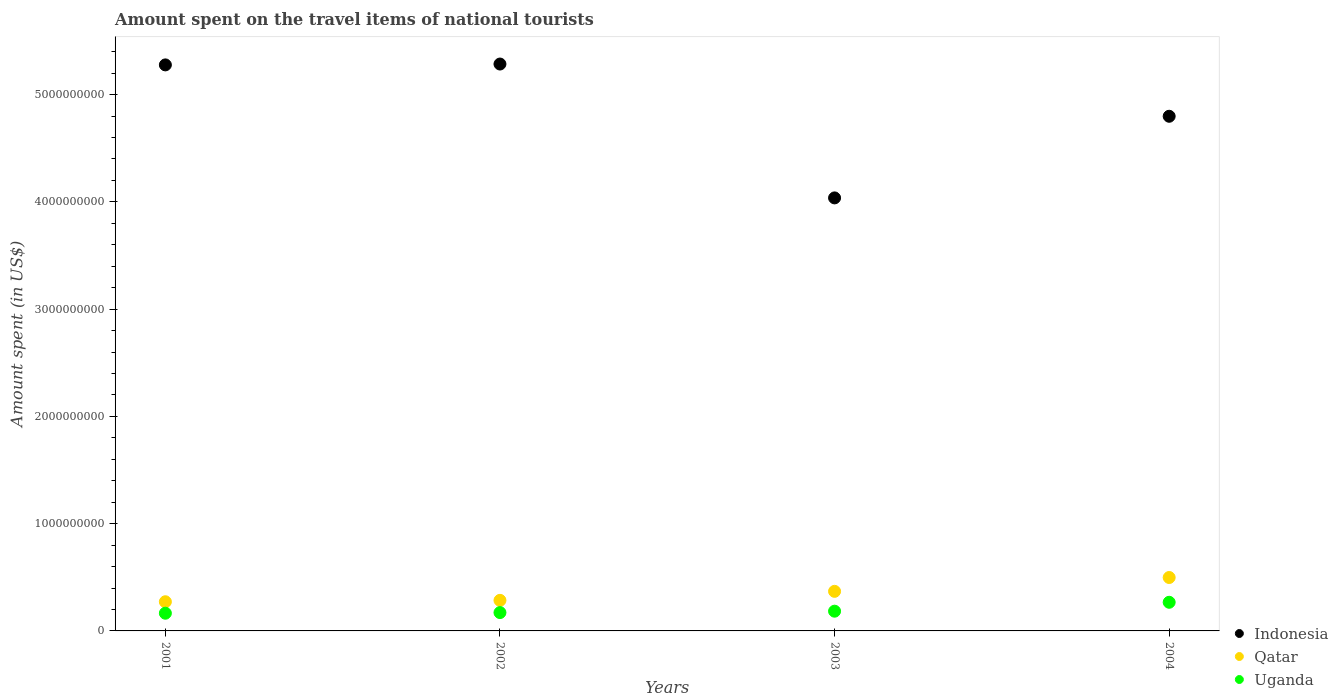Is the number of dotlines equal to the number of legend labels?
Make the answer very short. Yes. What is the amount spent on the travel items of national tourists in Qatar in 2004?
Provide a succinct answer. 4.98e+08. Across all years, what is the maximum amount spent on the travel items of national tourists in Uganda?
Make the answer very short. 2.67e+08. Across all years, what is the minimum amount spent on the travel items of national tourists in Indonesia?
Your answer should be very brief. 4.04e+09. What is the total amount spent on the travel items of national tourists in Indonesia in the graph?
Your answer should be compact. 1.94e+1. What is the difference between the amount spent on the travel items of national tourists in Qatar in 2002 and that in 2004?
Make the answer very short. -2.13e+08. What is the difference between the amount spent on the travel items of national tourists in Uganda in 2004 and the amount spent on the travel items of national tourists in Qatar in 2001?
Make the answer very short. -5.00e+06. What is the average amount spent on the travel items of national tourists in Qatar per year?
Provide a short and direct response. 3.56e+08. In the year 2003, what is the difference between the amount spent on the travel items of national tourists in Uganda and amount spent on the travel items of national tourists in Qatar?
Give a very brief answer. -1.85e+08. In how many years, is the amount spent on the travel items of national tourists in Qatar greater than 3200000000 US$?
Offer a very short reply. 0. What is the ratio of the amount spent on the travel items of national tourists in Indonesia in 2002 to that in 2003?
Keep it short and to the point. 1.31. Is the difference between the amount spent on the travel items of national tourists in Uganda in 2002 and 2004 greater than the difference between the amount spent on the travel items of national tourists in Qatar in 2002 and 2004?
Offer a terse response. Yes. What is the difference between the highest and the second highest amount spent on the travel items of national tourists in Uganda?
Your answer should be very brief. 8.30e+07. What is the difference between the highest and the lowest amount spent on the travel items of national tourists in Uganda?
Your answer should be very brief. 1.02e+08. Is it the case that in every year, the sum of the amount spent on the travel items of national tourists in Qatar and amount spent on the travel items of national tourists in Uganda  is greater than the amount spent on the travel items of national tourists in Indonesia?
Offer a very short reply. No. Does the amount spent on the travel items of national tourists in Indonesia monotonically increase over the years?
Your answer should be compact. No. Is the amount spent on the travel items of national tourists in Uganda strictly greater than the amount spent on the travel items of national tourists in Indonesia over the years?
Offer a very short reply. No. How many years are there in the graph?
Make the answer very short. 4. What is the difference between two consecutive major ticks on the Y-axis?
Give a very brief answer. 1.00e+09. Does the graph contain any zero values?
Provide a short and direct response. No. Where does the legend appear in the graph?
Your answer should be compact. Bottom right. What is the title of the graph?
Your response must be concise. Amount spent on the travel items of national tourists. What is the label or title of the X-axis?
Provide a succinct answer. Years. What is the label or title of the Y-axis?
Ensure brevity in your answer.  Amount spent (in US$). What is the Amount spent (in US$) of Indonesia in 2001?
Offer a terse response. 5.28e+09. What is the Amount spent (in US$) in Qatar in 2001?
Ensure brevity in your answer.  2.72e+08. What is the Amount spent (in US$) in Uganda in 2001?
Give a very brief answer. 1.65e+08. What is the Amount spent (in US$) in Indonesia in 2002?
Ensure brevity in your answer.  5.28e+09. What is the Amount spent (in US$) of Qatar in 2002?
Provide a succinct answer. 2.85e+08. What is the Amount spent (in US$) of Uganda in 2002?
Offer a very short reply. 1.71e+08. What is the Amount spent (in US$) of Indonesia in 2003?
Keep it short and to the point. 4.04e+09. What is the Amount spent (in US$) of Qatar in 2003?
Your answer should be very brief. 3.69e+08. What is the Amount spent (in US$) in Uganda in 2003?
Make the answer very short. 1.84e+08. What is the Amount spent (in US$) in Indonesia in 2004?
Ensure brevity in your answer.  4.80e+09. What is the Amount spent (in US$) in Qatar in 2004?
Provide a short and direct response. 4.98e+08. What is the Amount spent (in US$) of Uganda in 2004?
Make the answer very short. 2.67e+08. Across all years, what is the maximum Amount spent (in US$) of Indonesia?
Provide a short and direct response. 5.28e+09. Across all years, what is the maximum Amount spent (in US$) in Qatar?
Offer a terse response. 4.98e+08. Across all years, what is the maximum Amount spent (in US$) in Uganda?
Your answer should be very brief. 2.67e+08. Across all years, what is the minimum Amount spent (in US$) of Indonesia?
Offer a very short reply. 4.04e+09. Across all years, what is the minimum Amount spent (in US$) in Qatar?
Offer a terse response. 2.72e+08. Across all years, what is the minimum Amount spent (in US$) of Uganda?
Provide a short and direct response. 1.65e+08. What is the total Amount spent (in US$) of Indonesia in the graph?
Keep it short and to the point. 1.94e+1. What is the total Amount spent (in US$) in Qatar in the graph?
Offer a very short reply. 1.42e+09. What is the total Amount spent (in US$) of Uganda in the graph?
Offer a terse response. 7.87e+08. What is the difference between the Amount spent (in US$) in Indonesia in 2001 and that in 2002?
Your response must be concise. -8.00e+06. What is the difference between the Amount spent (in US$) in Qatar in 2001 and that in 2002?
Ensure brevity in your answer.  -1.30e+07. What is the difference between the Amount spent (in US$) in Uganda in 2001 and that in 2002?
Keep it short and to the point. -6.00e+06. What is the difference between the Amount spent (in US$) of Indonesia in 2001 and that in 2003?
Keep it short and to the point. 1.24e+09. What is the difference between the Amount spent (in US$) of Qatar in 2001 and that in 2003?
Offer a very short reply. -9.70e+07. What is the difference between the Amount spent (in US$) of Uganda in 2001 and that in 2003?
Keep it short and to the point. -1.90e+07. What is the difference between the Amount spent (in US$) in Indonesia in 2001 and that in 2004?
Offer a very short reply. 4.79e+08. What is the difference between the Amount spent (in US$) in Qatar in 2001 and that in 2004?
Keep it short and to the point. -2.26e+08. What is the difference between the Amount spent (in US$) of Uganda in 2001 and that in 2004?
Keep it short and to the point. -1.02e+08. What is the difference between the Amount spent (in US$) in Indonesia in 2002 and that in 2003?
Your response must be concise. 1.25e+09. What is the difference between the Amount spent (in US$) of Qatar in 2002 and that in 2003?
Provide a short and direct response. -8.40e+07. What is the difference between the Amount spent (in US$) of Uganda in 2002 and that in 2003?
Make the answer very short. -1.30e+07. What is the difference between the Amount spent (in US$) in Indonesia in 2002 and that in 2004?
Your answer should be very brief. 4.87e+08. What is the difference between the Amount spent (in US$) of Qatar in 2002 and that in 2004?
Ensure brevity in your answer.  -2.13e+08. What is the difference between the Amount spent (in US$) in Uganda in 2002 and that in 2004?
Offer a terse response. -9.60e+07. What is the difference between the Amount spent (in US$) in Indonesia in 2003 and that in 2004?
Keep it short and to the point. -7.61e+08. What is the difference between the Amount spent (in US$) of Qatar in 2003 and that in 2004?
Provide a succinct answer. -1.29e+08. What is the difference between the Amount spent (in US$) of Uganda in 2003 and that in 2004?
Your answer should be compact. -8.30e+07. What is the difference between the Amount spent (in US$) in Indonesia in 2001 and the Amount spent (in US$) in Qatar in 2002?
Provide a short and direct response. 4.99e+09. What is the difference between the Amount spent (in US$) in Indonesia in 2001 and the Amount spent (in US$) in Uganda in 2002?
Your answer should be compact. 5.11e+09. What is the difference between the Amount spent (in US$) of Qatar in 2001 and the Amount spent (in US$) of Uganda in 2002?
Ensure brevity in your answer.  1.01e+08. What is the difference between the Amount spent (in US$) in Indonesia in 2001 and the Amount spent (in US$) in Qatar in 2003?
Your response must be concise. 4.91e+09. What is the difference between the Amount spent (in US$) in Indonesia in 2001 and the Amount spent (in US$) in Uganda in 2003?
Ensure brevity in your answer.  5.09e+09. What is the difference between the Amount spent (in US$) of Qatar in 2001 and the Amount spent (in US$) of Uganda in 2003?
Provide a short and direct response. 8.80e+07. What is the difference between the Amount spent (in US$) of Indonesia in 2001 and the Amount spent (in US$) of Qatar in 2004?
Make the answer very short. 4.78e+09. What is the difference between the Amount spent (in US$) of Indonesia in 2001 and the Amount spent (in US$) of Uganda in 2004?
Ensure brevity in your answer.  5.01e+09. What is the difference between the Amount spent (in US$) in Indonesia in 2002 and the Amount spent (in US$) in Qatar in 2003?
Your answer should be compact. 4.92e+09. What is the difference between the Amount spent (in US$) of Indonesia in 2002 and the Amount spent (in US$) of Uganda in 2003?
Offer a very short reply. 5.10e+09. What is the difference between the Amount spent (in US$) of Qatar in 2002 and the Amount spent (in US$) of Uganda in 2003?
Keep it short and to the point. 1.01e+08. What is the difference between the Amount spent (in US$) in Indonesia in 2002 and the Amount spent (in US$) in Qatar in 2004?
Your answer should be compact. 4.79e+09. What is the difference between the Amount spent (in US$) in Indonesia in 2002 and the Amount spent (in US$) in Uganda in 2004?
Keep it short and to the point. 5.02e+09. What is the difference between the Amount spent (in US$) in Qatar in 2002 and the Amount spent (in US$) in Uganda in 2004?
Make the answer very short. 1.80e+07. What is the difference between the Amount spent (in US$) in Indonesia in 2003 and the Amount spent (in US$) in Qatar in 2004?
Make the answer very short. 3.54e+09. What is the difference between the Amount spent (in US$) in Indonesia in 2003 and the Amount spent (in US$) in Uganda in 2004?
Offer a very short reply. 3.77e+09. What is the difference between the Amount spent (in US$) of Qatar in 2003 and the Amount spent (in US$) of Uganda in 2004?
Your answer should be compact. 1.02e+08. What is the average Amount spent (in US$) in Indonesia per year?
Offer a very short reply. 4.85e+09. What is the average Amount spent (in US$) in Qatar per year?
Your answer should be very brief. 3.56e+08. What is the average Amount spent (in US$) in Uganda per year?
Offer a terse response. 1.97e+08. In the year 2001, what is the difference between the Amount spent (in US$) of Indonesia and Amount spent (in US$) of Qatar?
Offer a very short reply. 5.00e+09. In the year 2001, what is the difference between the Amount spent (in US$) in Indonesia and Amount spent (in US$) in Uganda?
Give a very brief answer. 5.11e+09. In the year 2001, what is the difference between the Amount spent (in US$) of Qatar and Amount spent (in US$) of Uganda?
Provide a short and direct response. 1.07e+08. In the year 2002, what is the difference between the Amount spent (in US$) of Indonesia and Amount spent (in US$) of Qatar?
Give a very brief answer. 5.00e+09. In the year 2002, what is the difference between the Amount spent (in US$) of Indonesia and Amount spent (in US$) of Uganda?
Your answer should be compact. 5.11e+09. In the year 2002, what is the difference between the Amount spent (in US$) in Qatar and Amount spent (in US$) in Uganda?
Give a very brief answer. 1.14e+08. In the year 2003, what is the difference between the Amount spent (in US$) of Indonesia and Amount spent (in US$) of Qatar?
Your answer should be very brief. 3.67e+09. In the year 2003, what is the difference between the Amount spent (in US$) in Indonesia and Amount spent (in US$) in Uganda?
Your response must be concise. 3.85e+09. In the year 2003, what is the difference between the Amount spent (in US$) of Qatar and Amount spent (in US$) of Uganda?
Provide a short and direct response. 1.85e+08. In the year 2004, what is the difference between the Amount spent (in US$) of Indonesia and Amount spent (in US$) of Qatar?
Ensure brevity in your answer.  4.30e+09. In the year 2004, what is the difference between the Amount spent (in US$) in Indonesia and Amount spent (in US$) in Uganda?
Provide a short and direct response. 4.53e+09. In the year 2004, what is the difference between the Amount spent (in US$) of Qatar and Amount spent (in US$) of Uganda?
Make the answer very short. 2.31e+08. What is the ratio of the Amount spent (in US$) in Qatar in 2001 to that in 2002?
Provide a succinct answer. 0.95. What is the ratio of the Amount spent (in US$) in Uganda in 2001 to that in 2002?
Offer a very short reply. 0.96. What is the ratio of the Amount spent (in US$) in Indonesia in 2001 to that in 2003?
Your answer should be compact. 1.31. What is the ratio of the Amount spent (in US$) of Qatar in 2001 to that in 2003?
Keep it short and to the point. 0.74. What is the ratio of the Amount spent (in US$) in Uganda in 2001 to that in 2003?
Your response must be concise. 0.9. What is the ratio of the Amount spent (in US$) in Indonesia in 2001 to that in 2004?
Provide a succinct answer. 1.1. What is the ratio of the Amount spent (in US$) of Qatar in 2001 to that in 2004?
Your response must be concise. 0.55. What is the ratio of the Amount spent (in US$) in Uganda in 2001 to that in 2004?
Offer a terse response. 0.62. What is the ratio of the Amount spent (in US$) in Indonesia in 2002 to that in 2003?
Offer a very short reply. 1.31. What is the ratio of the Amount spent (in US$) in Qatar in 2002 to that in 2003?
Your answer should be compact. 0.77. What is the ratio of the Amount spent (in US$) of Uganda in 2002 to that in 2003?
Keep it short and to the point. 0.93. What is the ratio of the Amount spent (in US$) of Indonesia in 2002 to that in 2004?
Offer a very short reply. 1.1. What is the ratio of the Amount spent (in US$) in Qatar in 2002 to that in 2004?
Your response must be concise. 0.57. What is the ratio of the Amount spent (in US$) in Uganda in 2002 to that in 2004?
Offer a very short reply. 0.64. What is the ratio of the Amount spent (in US$) of Indonesia in 2003 to that in 2004?
Your answer should be very brief. 0.84. What is the ratio of the Amount spent (in US$) in Qatar in 2003 to that in 2004?
Your answer should be compact. 0.74. What is the ratio of the Amount spent (in US$) of Uganda in 2003 to that in 2004?
Provide a succinct answer. 0.69. What is the difference between the highest and the second highest Amount spent (in US$) in Indonesia?
Give a very brief answer. 8.00e+06. What is the difference between the highest and the second highest Amount spent (in US$) in Qatar?
Keep it short and to the point. 1.29e+08. What is the difference between the highest and the second highest Amount spent (in US$) of Uganda?
Keep it short and to the point. 8.30e+07. What is the difference between the highest and the lowest Amount spent (in US$) of Indonesia?
Your response must be concise. 1.25e+09. What is the difference between the highest and the lowest Amount spent (in US$) of Qatar?
Keep it short and to the point. 2.26e+08. What is the difference between the highest and the lowest Amount spent (in US$) in Uganda?
Your response must be concise. 1.02e+08. 